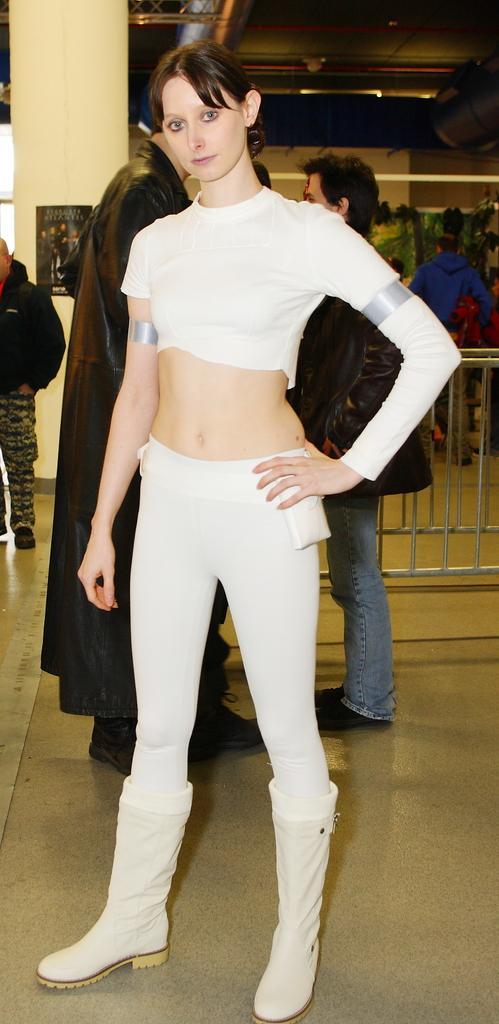Could you give a brief overview of what you see in this image? In this image I can see a woman standing and wearing white dress and white shoe. Back Side I can see few people and one is holding bag. I can see a fencing and pamphlet is attached to the pillar. 